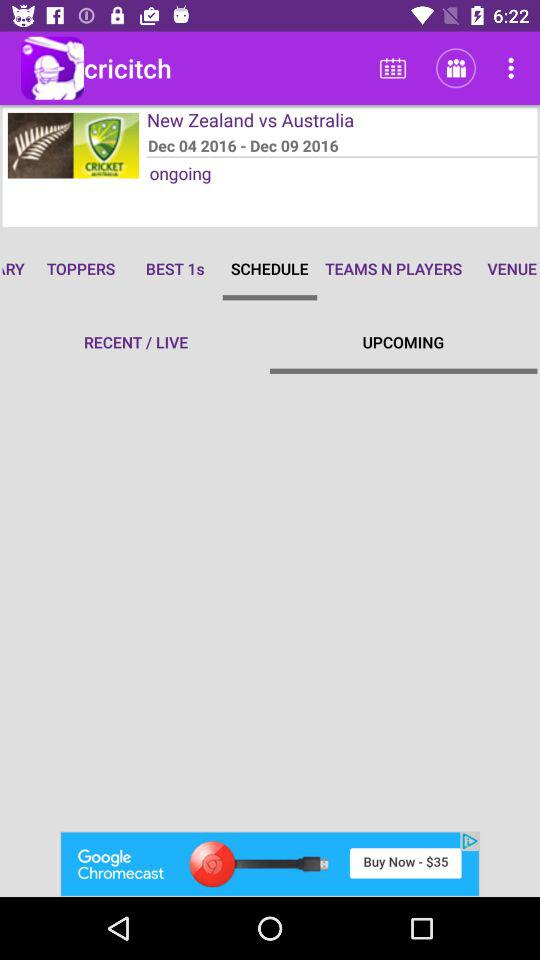What is the mentioned date range of the series between "New Zealand" and "Australia"? The mentioned date range of the series between "New Zealand" and "Australia" is from December 4, 2016 to December 9, 2016. 